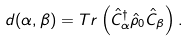Convert formula to latex. <formula><loc_0><loc_0><loc_500><loc_500>d ( \alpha , \beta ) = T r \left ( \hat { C } _ { \alpha } ^ { \dagger } \hat { \rho } _ { 0 } \hat { C } _ { \beta } \right ) .</formula> 